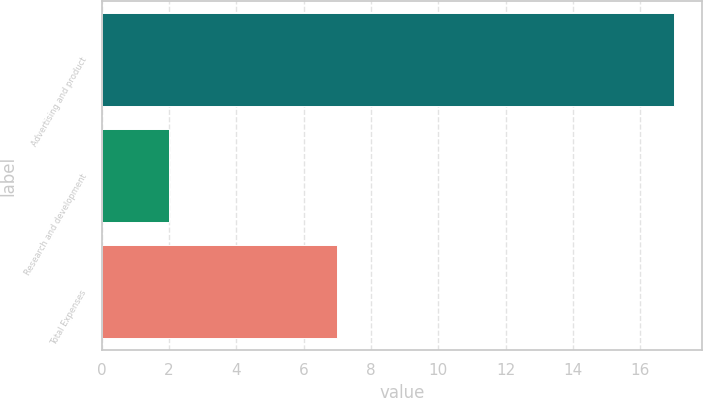<chart> <loc_0><loc_0><loc_500><loc_500><bar_chart><fcel>Advertising and product<fcel>Research and development<fcel>Total Expenses<nl><fcel>17<fcel>2<fcel>7<nl></chart> 